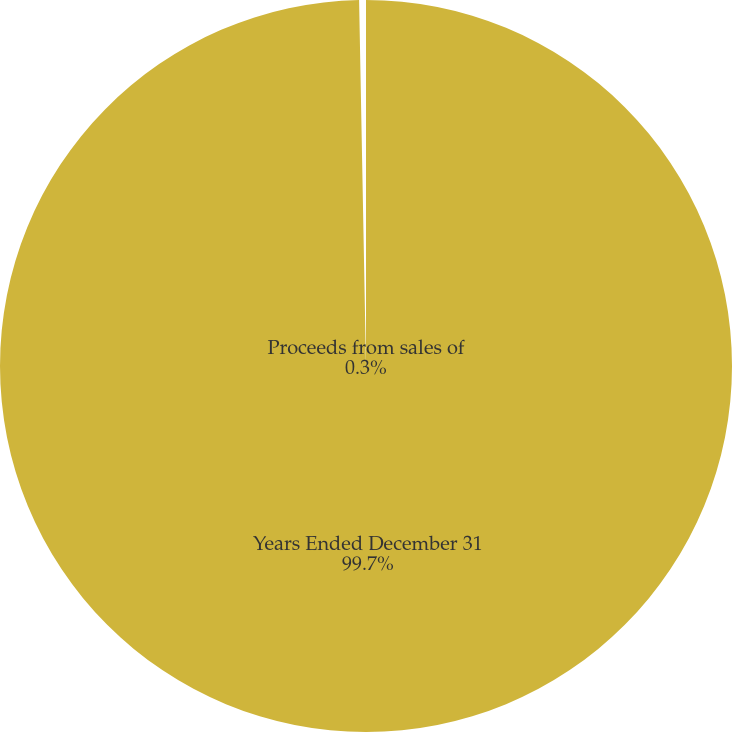Convert chart to OTSL. <chart><loc_0><loc_0><loc_500><loc_500><pie_chart><fcel>Years Ended December 31<fcel>Proceeds from sales of<nl><fcel>99.7%<fcel>0.3%<nl></chart> 